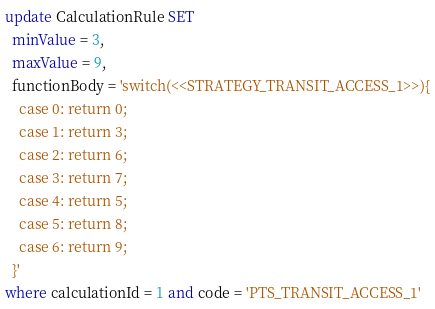<code> <loc_0><loc_0><loc_500><loc_500><_SQL_>update CalculationRule SET
  minValue = 3,
  maxValue = 9,
  functionBody = 'switch(<<STRATEGY_TRANSIT_ACCESS_1>>){
    case 0: return 0;
    case 1: return 3;
    case 2: return 6;
	case 3: return 7;
    case 4: return 5;
	case 5: return 8;
    case 6: return 9;
  }'
where calculationId = 1 and code = 'PTS_TRANSIT_ACCESS_1'</code> 